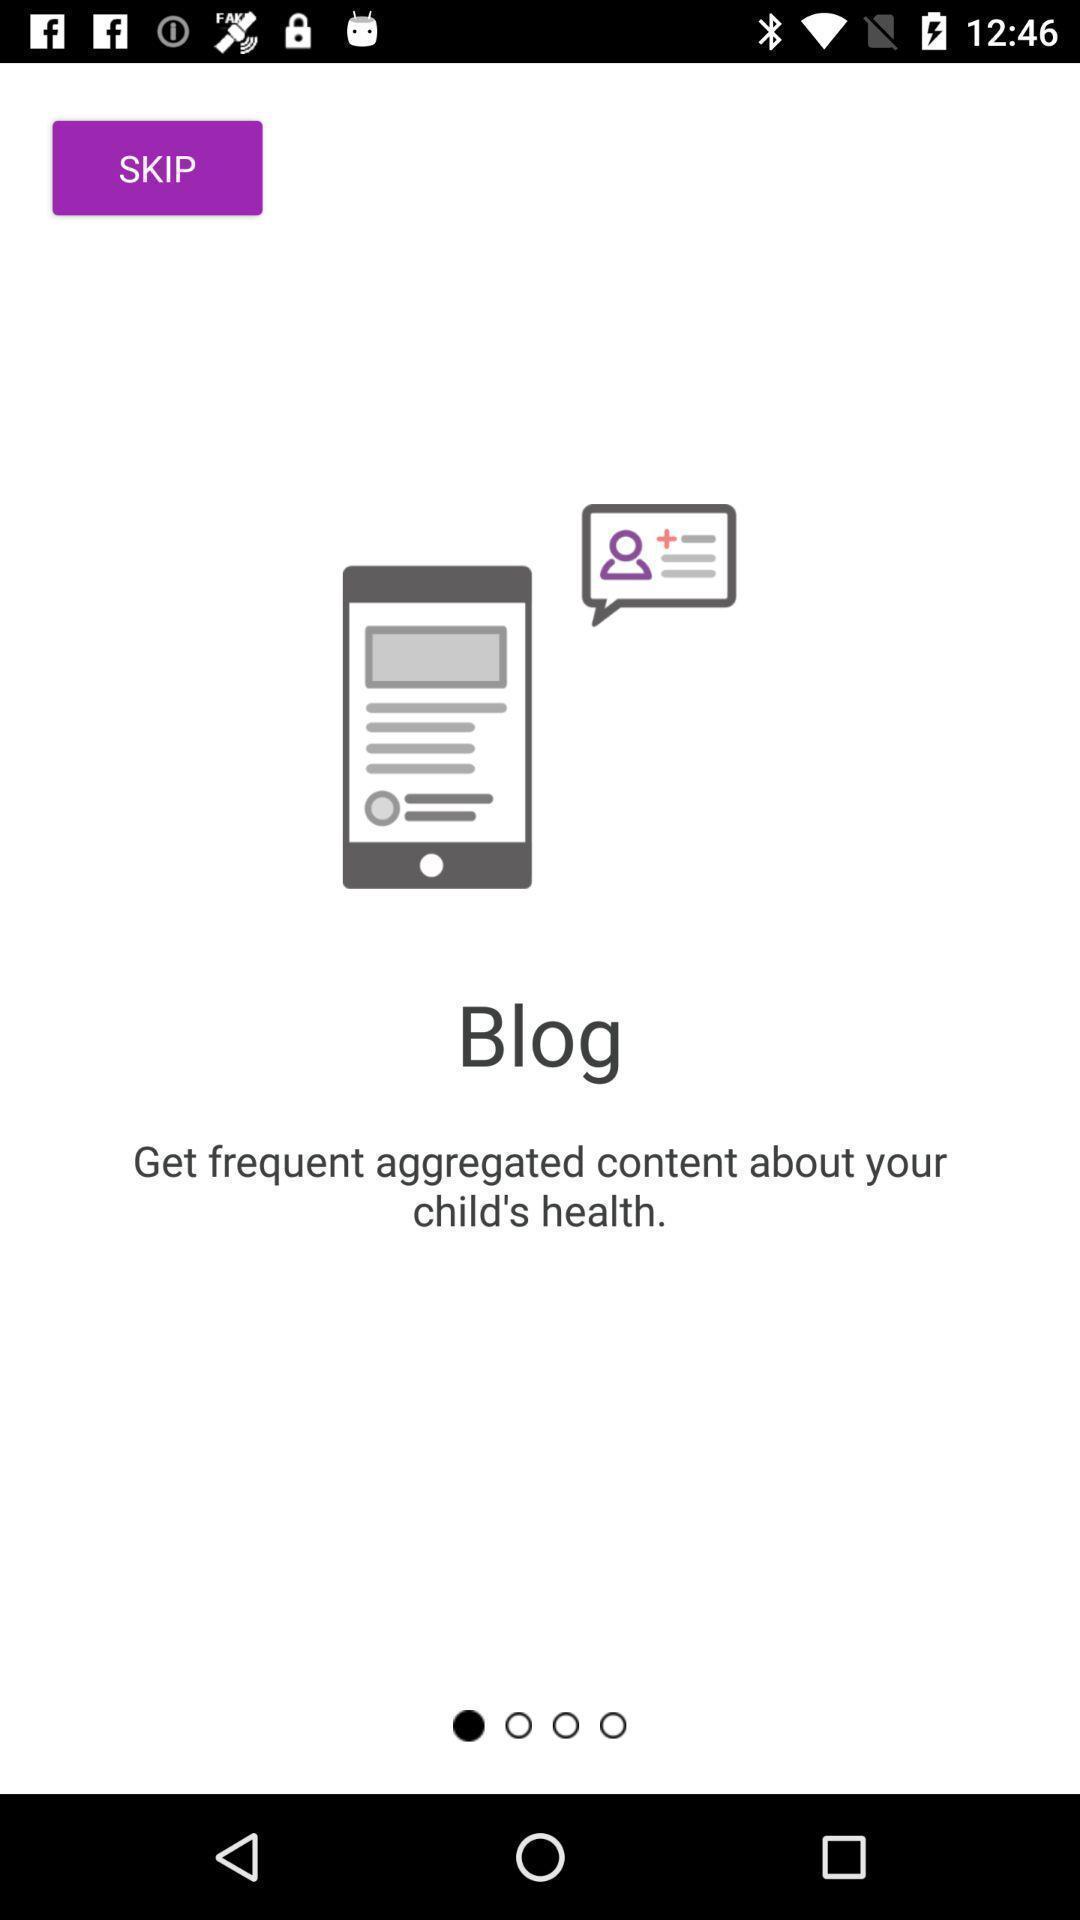Describe the key features of this screenshot. Welcome page displayed of an doctor application. 